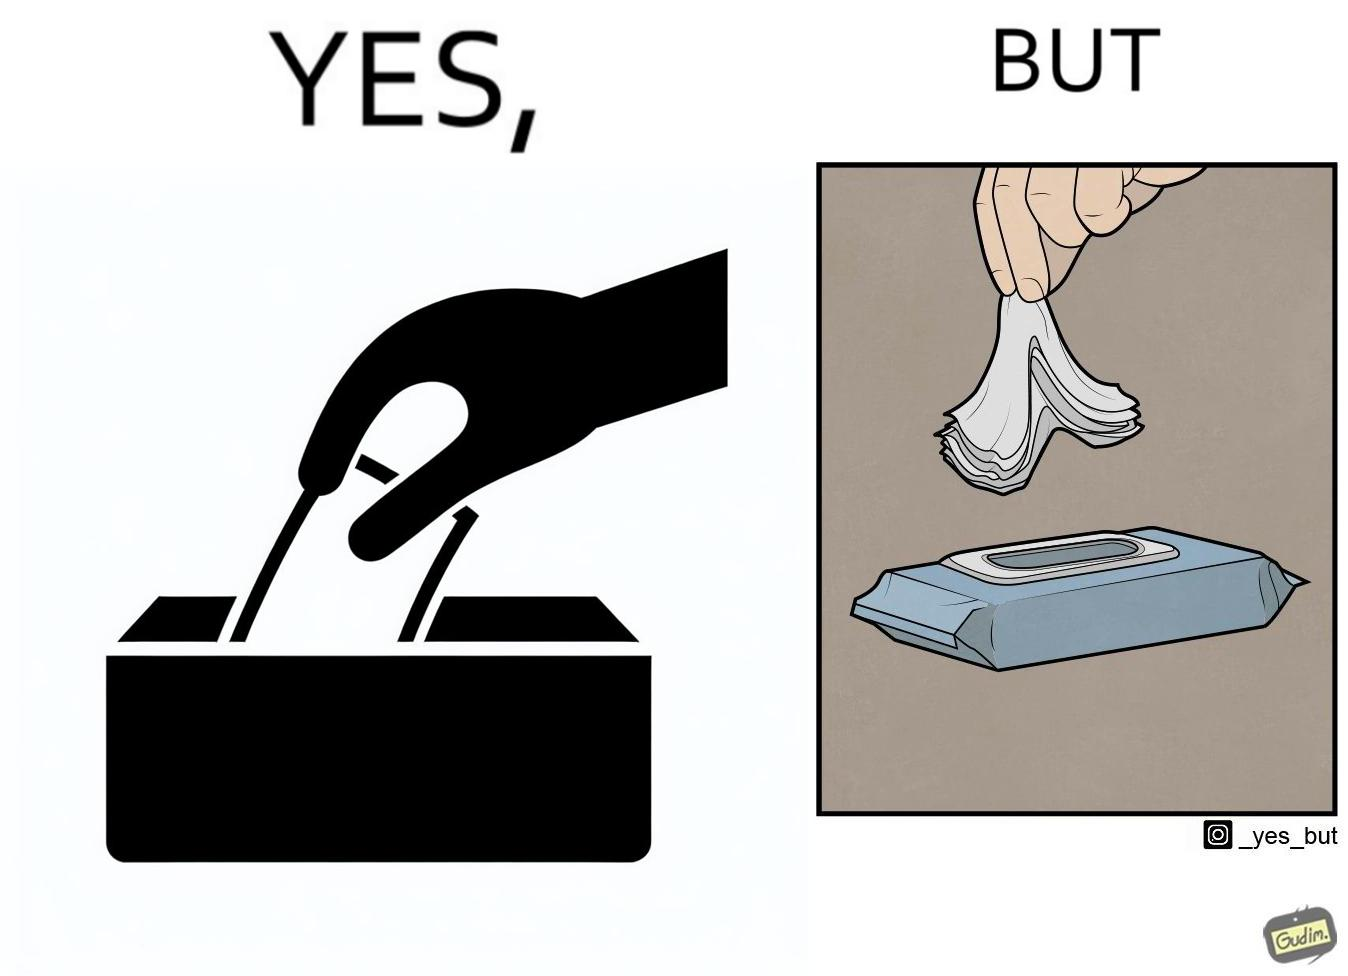Why is this image considered satirical? The image is ironic, because even when there is a need of only one napkin but the napkins are so tightly packed that more than one napkin gets out sticked together 